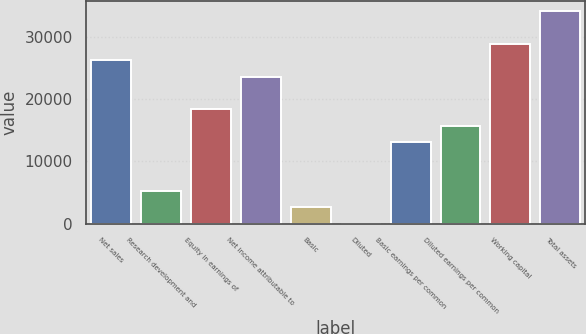Convert chart. <chart><loc_0><loc_0><loc_500><loc_500><bar_chart><fcel>Net sales<fcel>Research development and<fcel>Equity in earnings of<fcel>Net income attributable to<fcel>Basic<fcel>Diluted<fcel>Basic earnings per common<fcel>Diluted earnings per common<fcel>Working capital<fcel>Total assets<nl><fcel>26200<fcel>5241.81<fcel>18340.7<fcel>23580.2<fcel>2622.03<fcel>2.25<fcel>13101.1<fcel>15720.9<fcel>28819.8<fcel>34059.4<nl></chart> 